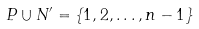<formula> <loc_0><loc_0><loc_500><loc_500>P \cup N ^ { \prime } = \{ 1 , 2 , \dots , n - 1 \}</formula> 